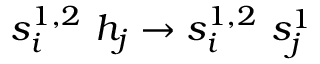<formula> <loc_0><loc_0><loc_500><loc_500>s _ { i } ^ { 1 , 2 } \ h _ { j } \to s _ { i } ^ { 1 , 2 } \ s _ { j } ^ { 1 }</formula> 